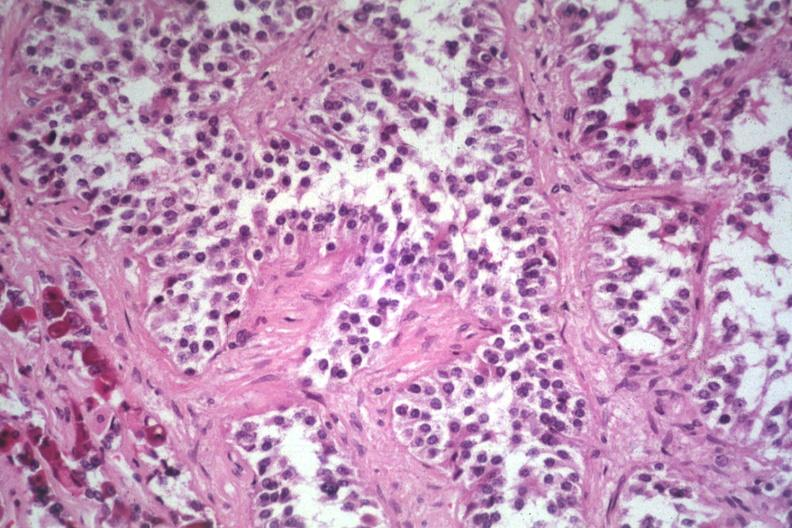s adenoma present?
Answer the question using a single word or phrase. Yes 